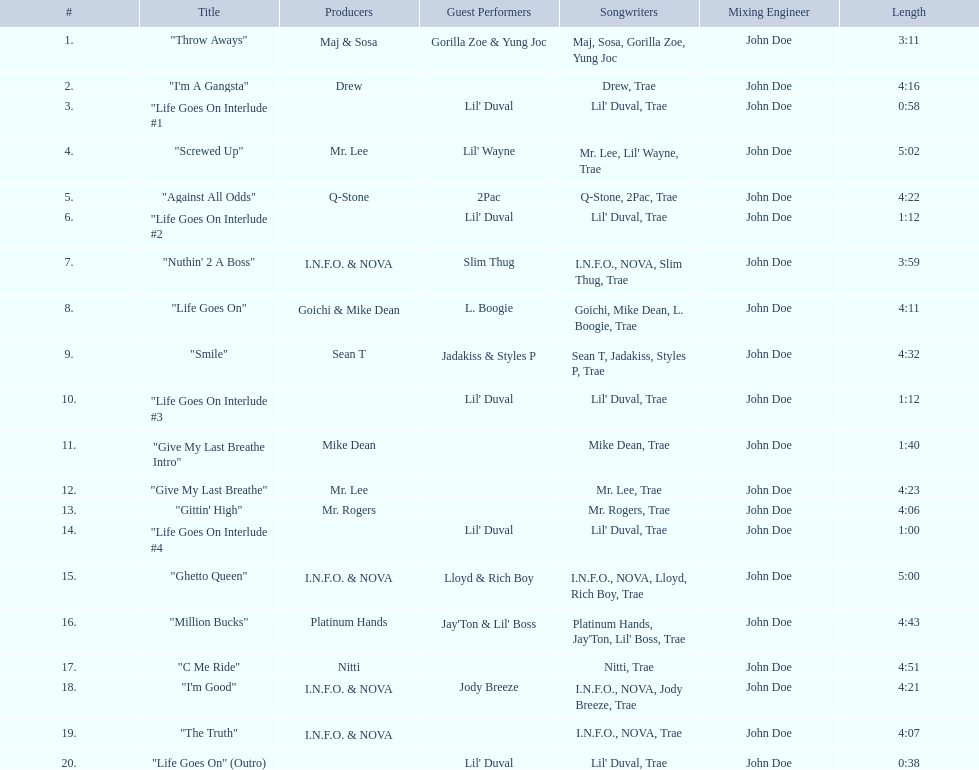What is the number of tracks featuring 2pac? 1. 